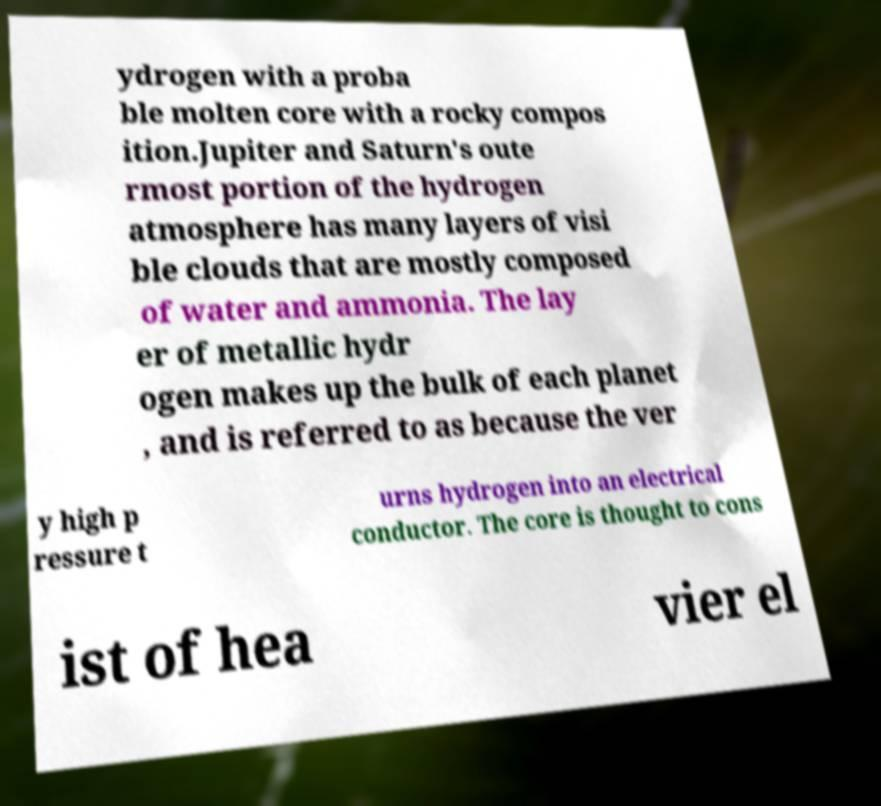I need the written content from this picture converted into text. Can you do that? ydrogen with a proba ble molten core with a rocky compos ition.Jupiter and Saturn's oute rmost portion of the hydrogen atmosphere has many layers of visi ble clouds that are mostly composed of water and ammonia. The lay er of metallic hydr ogen makes up the bulk of each planet , and is referred to as because the ver y high p ressure t urns hydrogen into an electrical conductor. The core is thought to cons ist of hea vier el 